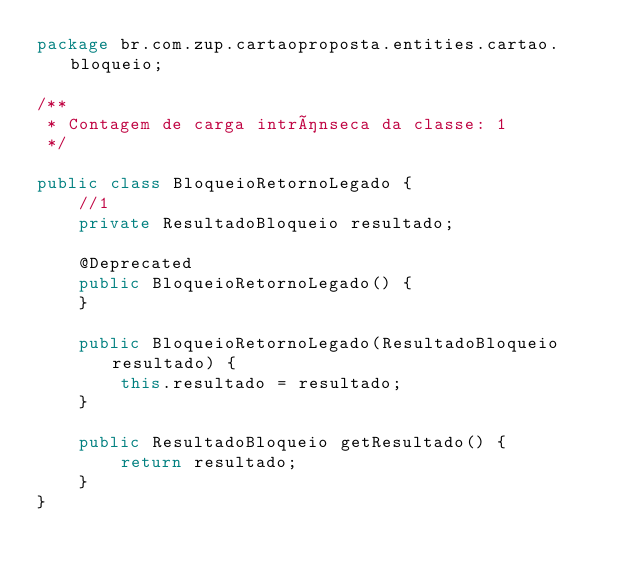<code> <loc_0><loc_0><loc_500><loc_500><_Java_>package br.com.zup.cartaoproposta.entities.cartao.bloqueio;

/**
 * Contagem de carga intrínseca da classe: 1
 */

public class BloqueioRetornoLegado {
    //1
    private ResultadoBloqueio resultado;

    @Deprecated
    public BloqueioRetornoLegado() {
    }

    public BloqueioRetornoLegado(ResultadoBloqueio resultado) {
        this.resultado = resultado;
    }

    public ResultadoBloqueio getResultado() {
        return resultado;
    }
}
</code> 